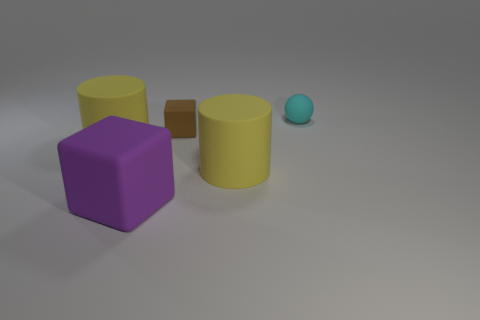Add 3 small matte cubes. How many objects exist? 8 Subtract 1 balls. How many balls are left? 0 Subtract all cyan cylinders. Subtract all gray spheres. How many cylinders are left? 2 Subtract all large purple metallic objects. Subtract all cyan objects. How many objects are left? 4 Add 2 tiny brown things. How many tiny brown things are left? 3 Add 2 brown rubber things. How many brown rubber things exist? 3 Subtract 0 cyan cubes. How many objects are left? 5 Subtract all cylinders. How many objects are left? 3 